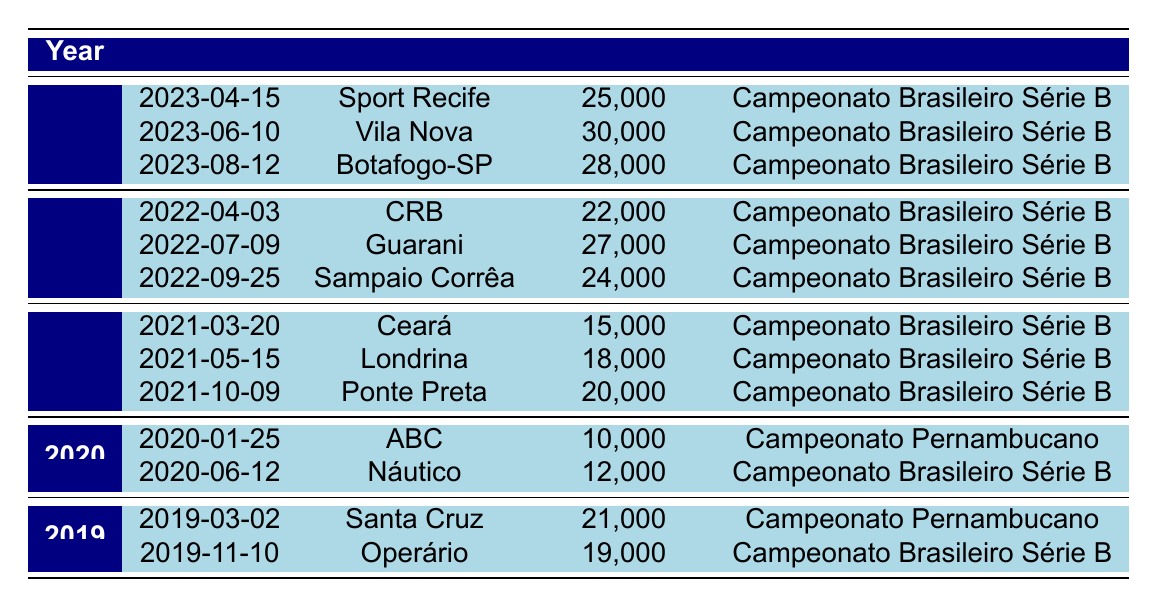What was the highest attendance recorded for Náutico home games in 2023? The table shows three matches for the year 2023, with attendances of 25000, 30000, and 28000. The highest value among these is 30000, which occurred during the match against Vila Nova on June 10, 2023.
Answer: 30000 How many total attendees were present at Náutico home games in 2022? In 2022, the attendances were 22000, 27000, and 24000. Adding these values gives 22000 + 27000 + 24000 = 73000. Therefore, the total attendance for 2022 was 73000.
Answer: 73000 Did Náutico have any games with an attendance of over 25000 in 2021? There were three games in 2021 with attendances of 15000, 18000, and 20000. All these values are less than 25000, so the answer is no.
Answer: No What was the average attendance for Náutico home games in 2020? Náutico had two matches in 2020 with attendances of 10000 and 12000. To find the average, we sum the attendances (10000 + 12000 = 22000) and divide by the number of matches (2). Thus, the average attendance is 22000 / 2 = 11000.
Answer: 11000 Which opponent had the highest attendance against Náutico in the last five seasons? Looking through all the recorded attendances from 2019 to 2023, the highest attendance was 30000 against Vila Nova in 2023. Therefore, the opponent with the highest attendance is Vila Nova.
Answer: Vila Nova How many matches did Náutico play at home in 2021? The table lists three matches for 2021. Therefore, Náutico played three home games that year.
Answer: 3 Was there any home game in 2020 with attendance more than 15000? There were two games in 2020 with attendances of 10000 and 12000. Both are less than 15000, confirming that there were no games with an attendance over 15000.
Answer: No Which year had the lowest recorded attendance for Náutico home games? In the table, the lowest attendance for Náutico occurs in 2020 with a total of 10000 during the match against ABC. Hence, 2020 is the year with the lowest attendance.
Answer: 2020 